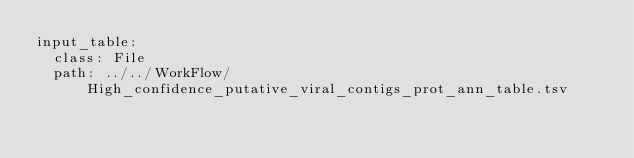<code> <loc_0><loc_0><loc_500><loc_500><_YAML_>input_table:
  class: File
  path: ../../WorkFlow/High_confidence_putative_viral_contigs_prot_ann_table.tsv</code> 